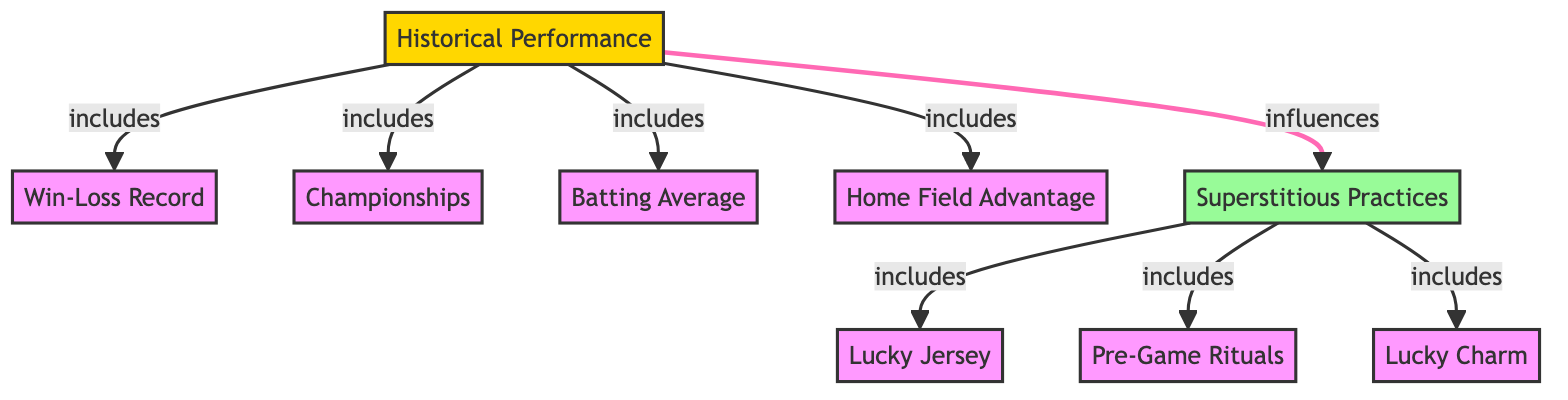What are the main components influencing Richmond Spiders' historical performance? The main components influencing Richmond Spiders' historical performance include win-loss record, championships, batting average, home field advantage, and superstitious practices. This can be seen as the performance node has arrows connecting to these specific aspects.
Answer: win-loss record, championships, batting average, home field advantage, superstitious practices How many superstitious practices are listed in the diagram? The diagram shows three superstitious practices: lucky jersey, pre-game rituals, and lucky charm. These are all connected under the superstitious practices node, indicating that there are three sub-components.
Answer: 3 What is the relationship between performance and superstitious practices? The relationship illustrated in the diagram shows that performance influences superstitious practices, indicated by the arrow going from performance to superstitious practices. This means the way the team performs can affect their superstitious behavior.
Answer: influences Which aspect of performance does home field advantage belong to? Home field advantage is included under the historical performance node, as shown by the direct connection from the performance node to home field advantage. It is one of the components that define overall performance.
Answer: historical performance What are the specific components of superstitious practices? The specific components of superstitious practices include lucky jersey, pre-game rituals, and lucky charm. These can be found as direct sub-nodes under the superstitious practices node in the diagram.
Answer: lucky jersey, pre-game rituals, lucky charm How many main nodes are present in the diagram? In the diagram, there are six main nodes: Historical Performance, Win-Loss Record, Championships, Batting Average, Home Field Advantage, and Superstitious Practices. Counting all these nodes gives us the total number of main components depicted.
Answer: 6 What color represents superstitious practices in the diagram? Superstitious practices are represented in a light green color, as indicated by the color coding in the diagram that classifies different nodes with various colors.
Answer: light green Is batting average a separate component from win-loss record? Yes, batting average is a separate component from win-loss record. The arrows originating from the performance node clearly indicate that they are individually considered as part of the overall performance.
Answer: Yes 